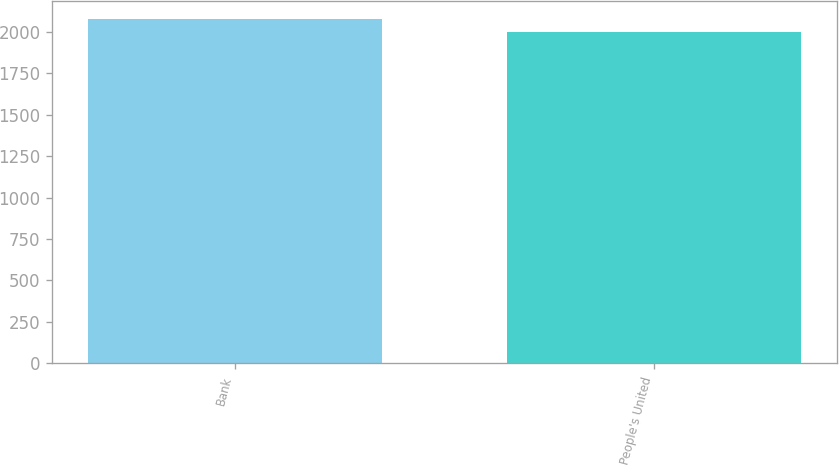Convert chart to OTSL. <chart><loc_0><loc_0><loc_500><loc_500><bar_chart><fcel>Bank<fcel>People's United<nl><fcel>2078.7<fcel>1995.4<nl></chart> 